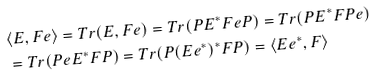<formula> <loc_0><loc_0><loc_500><loc_500>& \langle E , F e \rangle = T r ( E , F e ) = T r ( P E ^ { * } F e P ) = T r ( P E ^ { * } F P e ) \\ & = T r ( P e E ^ { * } F P ) = T r ( P ( E e ^ { * } ) ^ { * } F P ) = \langle E e ^ { * } , F \rangle</formula> 